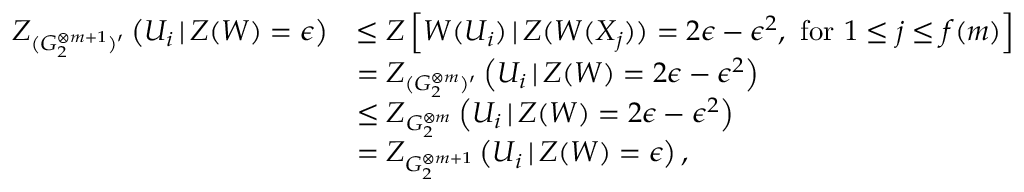<formula> <loc_0><loc_0><loc_500><loc_500>\begin{array} { r l } { Z _ { ( G _ { 2 } ^ { \otimes m + 1 } ) ^ { \prime } } \left ( U _ { i } \, | \, Z ( W ) = \epsilon \right ) } & { \leq Z \left [ W ( U _ { i } ) \, | \, Z ( W ( X _ { j } ) ) = 2 \epsilon - \epsilon ^ { 2 } , f o r 1 \leq j \leq f ( m ) \right ] } \\ & { = Z _ { ( G _ { 2 } ^ { \otimes m } ) ^ { \prime } } \left ( U _ { i } \, | \, Z ( W ) = 2 \epsilon - \epsilon ^ { 2 } \right ) } \\ & { \leq Z _ { G _ { 2 } ^ { \otimes m } } \left ( U _ { i } \, | \, Z ( W ) = 2 \epsilon - \epsilon ^ { 2 } \right ) } \\ & { = Z _ { G _ { 2 } ^ { \otimes m + 1 } } \left ( U _ { i } \, | \, Z ( W ) = \epsilon \right ) , } \end{array}</formula> 